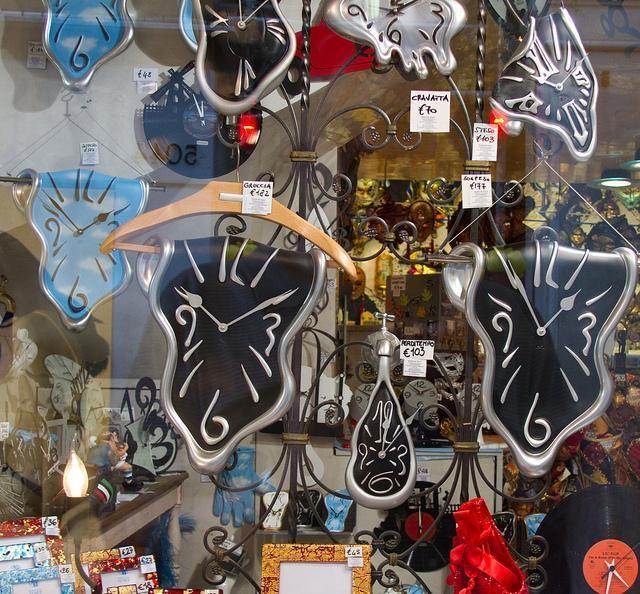How many clocks are there?
Give a very brief answer. 11. 